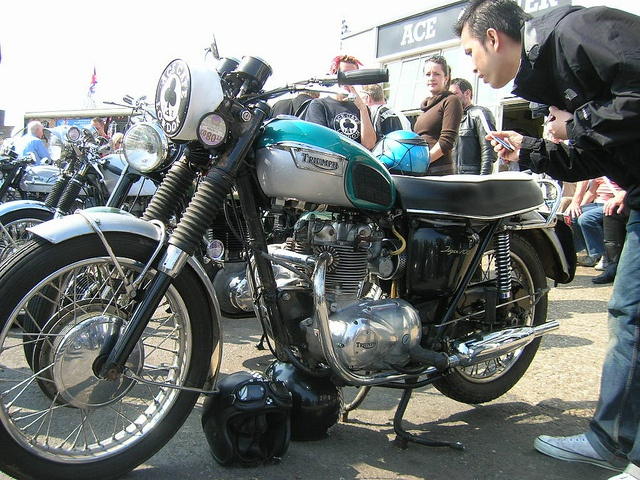Describe the objects in this image and their specific colors. I can see motorcycle in white, black, gray, and darkgray tones, people in white, black, gray, and darkgray tones, motorcycle in white, black, gray, and darkgray tones, people in white, gray, black, and tan tones, and people in white, gray, darkgray, and black tones in this image. 